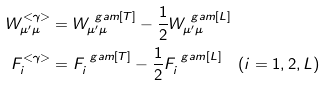Convert formula to latex. <formula><loc_0><loc_0><loc_500><loc_500>W _ { \mu ^ { \prime } \mu } ^ { < \gamma > } & = W _ { \mu ^ { \prime } \mu } ^ { \ g a m [ T ] } - \frac { 1 } { 2 } W _ { \mu ^ { \prime } \mu } ^ { \ g a m [ L ] } \\ F _ { i } ^ { < \gamma > } & = F _ { i } ^ { \ g a m [ T ] } - \frac { 1 } { 2 } F _ { i } ^ { \ g a m [ L ] } \quad ( i = 1 , 2 , L )</formula> 